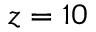Convert formula to latex. <formula><loc_0><loc_0><loc_500><loc_500>z = 1 0</formula> 